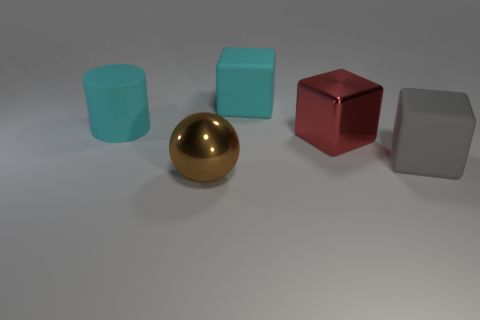Add 5 big gray matte cubes. How many objects exist? 10 Subtract all blocks. How many objects are left? 2 Add 5 tiny green rubber objects. How many tiny green rubber objects exist? 5 Subtract 1 gray blocks. How many objects are left? 4 Subtract all big gray objects. Subtract all big brown metal things. How many objects are left? 3 Add 2 large red things. How many large red things are left? 3 